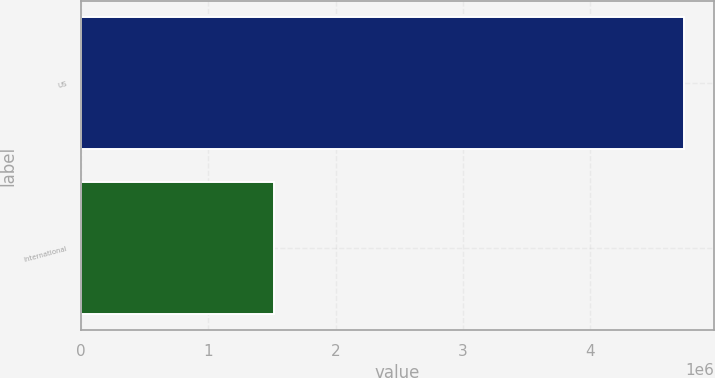Convert chart. <chart><loc_0><loc_0><loc_500><loc_500><bar_chart><fcel>US<fcel>International<nl><fcel>4.739e+06<fcel>1.512e+06<nl></chart> 